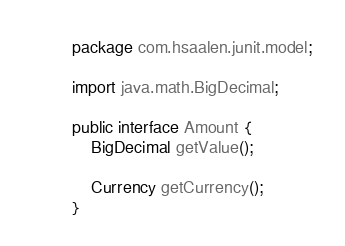<code> <loc_0><loc_0><loc_500><loc_500><_Java_>package com.hsaalen.junit.model;

import java.math.BigDecimal;

public interface Amount {
	BigDecimal getValue();

	Currency getCurrency();
}
</code> 